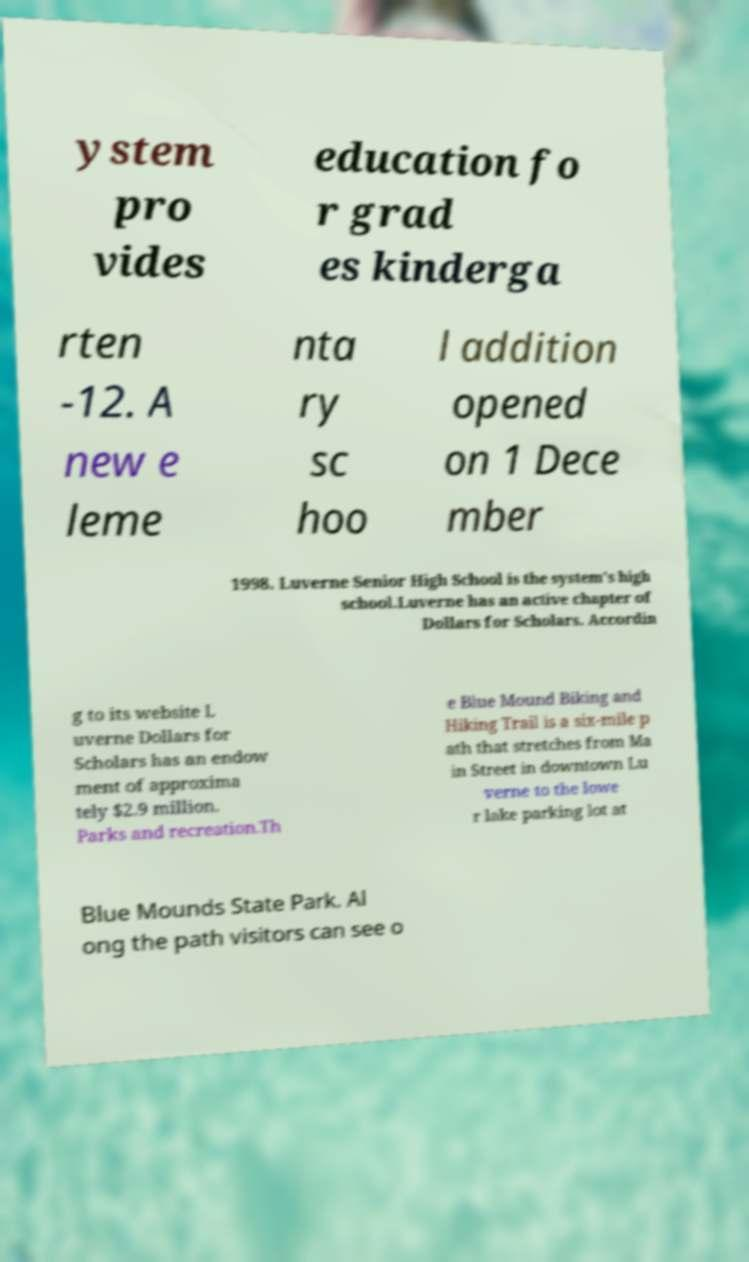There's text embedded in this image that I need extracted. Can you transcribe it verbatim? ystem pro vides education fo r grad es kinderga rten -12. A new e leme nta ry sc hoo l addition opened on 1 Dece mber 1998. Luverne Senior High School is the system's high school.Luverne has an active chapter of Dollars for Scholars. Accordin g to its website L uverne Dollars for Scholars has an endow ment of approxima tely $2.9 million. Parks and recreation.Th e Blue Mound Biking and Hiking Trail is a six-mile p ath that stretches from Ma in Street in downtown Lu verne to the lowe r lake parking lot at Blue Mounds State Park. Al ong the path visitors can see o 